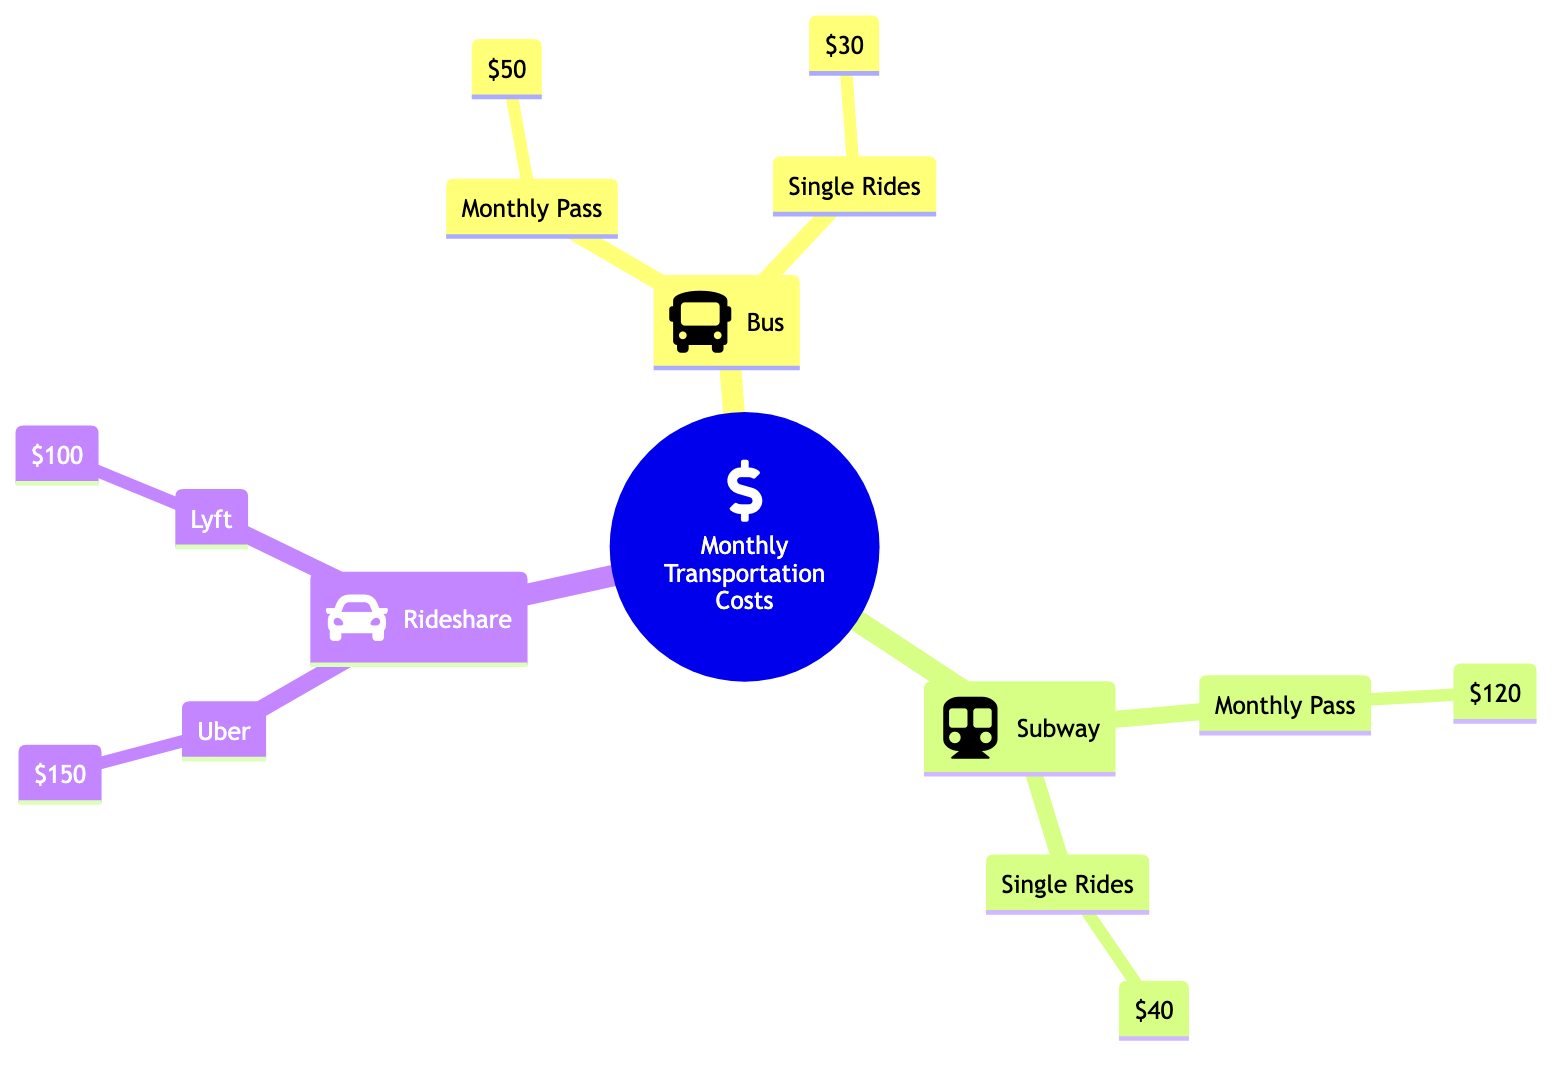What is the cost of a monthly subway pass? The diagram indicates the cost of a monthly subway pass directly under the Subway node, which is clearly labeled as $120.
Answer: $120 What are the two rideshare options listed? The Rideshare node has two sub-nodes: Uber and Lyft. These options are directly shown under the Rideshare category.
Answer: Uber, Lyft How much do single rides on the bus cost in total? The Single Rides under the Bus node shows $30. Since there is only one value presented, no additional calculations are necessary, and the total is simply that value.
Answer: $30 What is the total cost of a monthly pass for bus and subway combined? The Monthly Pass for Bus is $50 and for Subway is $120. Adding these two values together gives $50 + $120 = $170.
Answer: $170 Which transportation type has the highest single ride cost? By examining the Single Rides costs: Bus at $30, Subway at $40, Uber at $150, and Lyft at $100, we find that Uber at $150 is the highest among them.
Answer: Uber What is the total transportation cost if using only Uber for rides? The Rideshare node indicates that using Uber costs $150 for a single ride. Since the question pertains to using only Uber, the total cost remains just this one value without any additional costs to combine.
Answer: $150 How many distinct transportation categories are shown in the diagram? The diagram displays three distinct categories: Bus, Subway, and Rideshare. Counting these gives us 3 categories total.
Answer: 3 What is the difference in cost between a monthly pass for the subway and a single ride on the bus? The monthly pass for the subway costs $120, and a single ride on the bus costs $30. To find the difference, we calculate $120 - $30 = $90.
Answer: $90 What is the total cost for a monthly transportation expense if someone uses all monthly passes? The monthly pass for Bus is $50, and for Subway is $120. To find the total monthly cost for both, $50 + $120 = $170. Rideshare is not included as it's only for single rides.
Answer: $170 